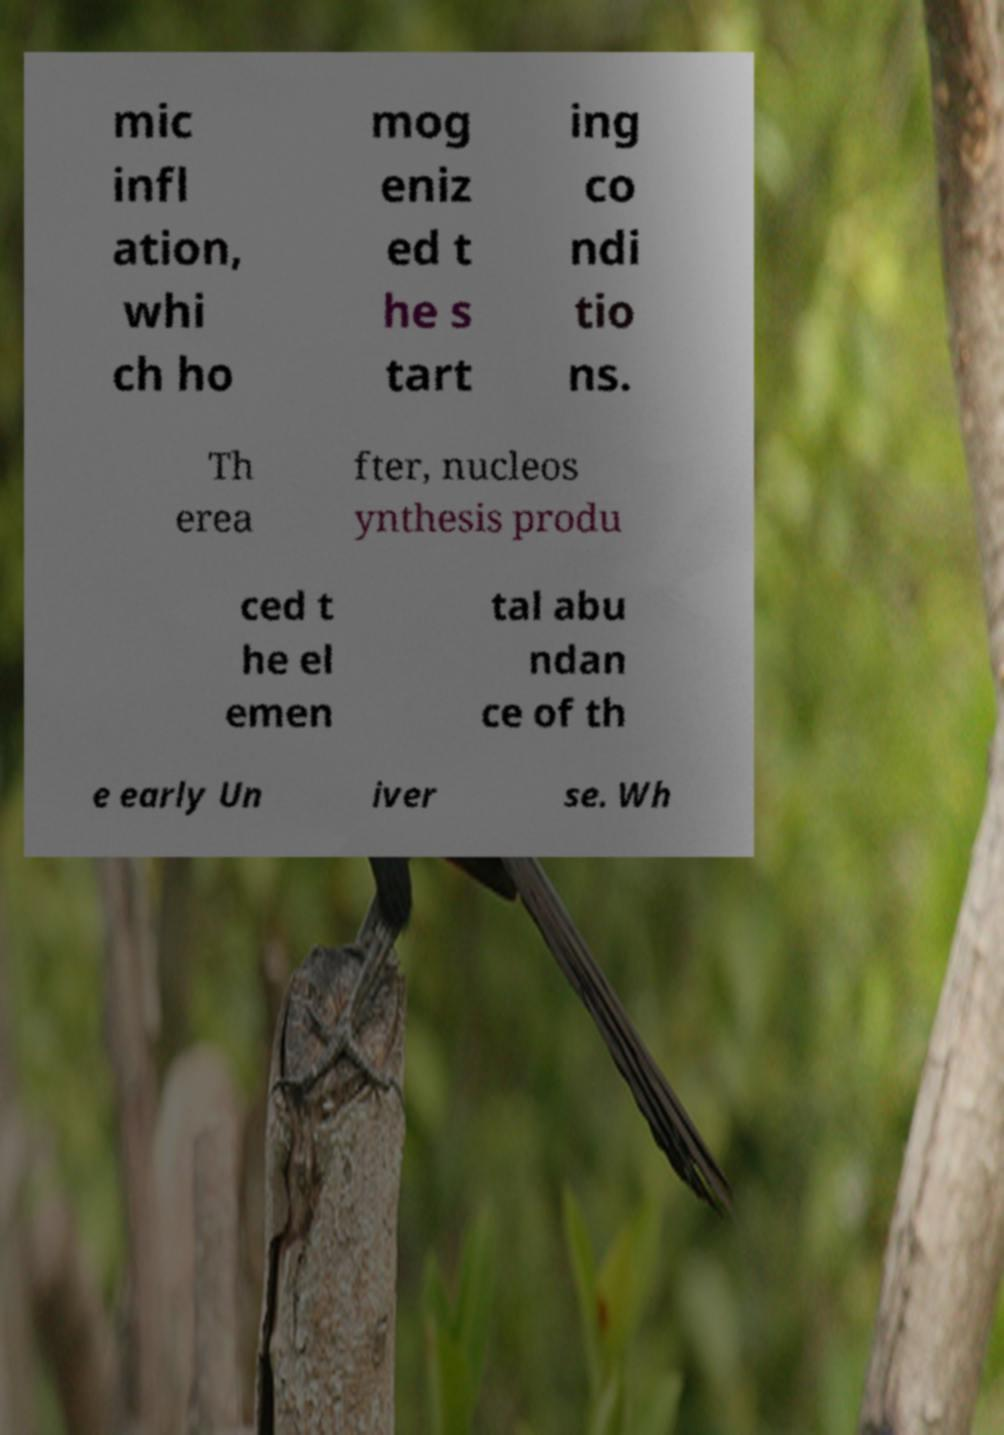Could you extract and type out the text from this image? mic infl ation, whi ch ho mog eniz ed t he s tart ing co ndi tio ns. Th erea fter, nucleos ynthesis produ ced t he el emen tal abu ndan ce of th e early Un iver se. Wh 